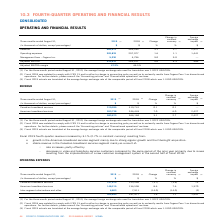According to Cogeco's financial document, What was the foreign exchange rate used for the three-month period ended 2019? According to the financial document, 1.3222 USD/CDN.. The relevant text states: "age foreign exchange rate used for translation was 1.3222 USD/CDN...." Also, What was the foreign exchange rate used For the three-month period ended 2018? According to the financial document, 1.3100 USD/CDN.. The relevant text states: "of the comparable period of fiscal 2018 which was 1.3100 USD/CDN...." Also, What was the Adjusted EBITDA margin in fourth quarter fiscal year 2019? According to the financial document, 47.2%. The relevant text states: "Adjusted EBITDA margin 47.2% 46.5%..." Also, can you calculate: What was the increase / (decrease) in the revenue from three months ended August 31, 2018 to 2019? Based on the calculation: 583,673 - 566,184, the result is 17489 (in thousands). This is based on the information: "Revenue 583,673 566,184 3.1 2.7 2,427 Revenue 583,673 566,184 3.1 2.7 2,427..." The key data points involved are: 566,184, 583,673. Also, can you calculate: What was the average operating expenses from three months ended August 31, 2018 to 2019? To answer this question, I need to perform calculations using the financial data. The calculation is: (302,833 + 297,977) / 2, which equals 300405 (in thousands). This is based on the information: "Operating expenses 302,833 297,977 1.6 1.1 1,441 Operating expenses 302,833 297,977 1.6 1.1 1,441..." The key data points involved are: 297,977, 302,833. Also, can you calculate: What was the increase / (decrease) in the Adjusted EBITDA margin from three months ended August 31, 2018 to 2019? Based on the calculation: 47.2% - 46.5%, the result is 0.7 (percentage). This is based on the information: "Adjusted EBITDA margin 47.2% 46.5% Adjusted EBITDA margin 47.2% 46.5%..." The key data points involved are: 46.5, 47.2. 